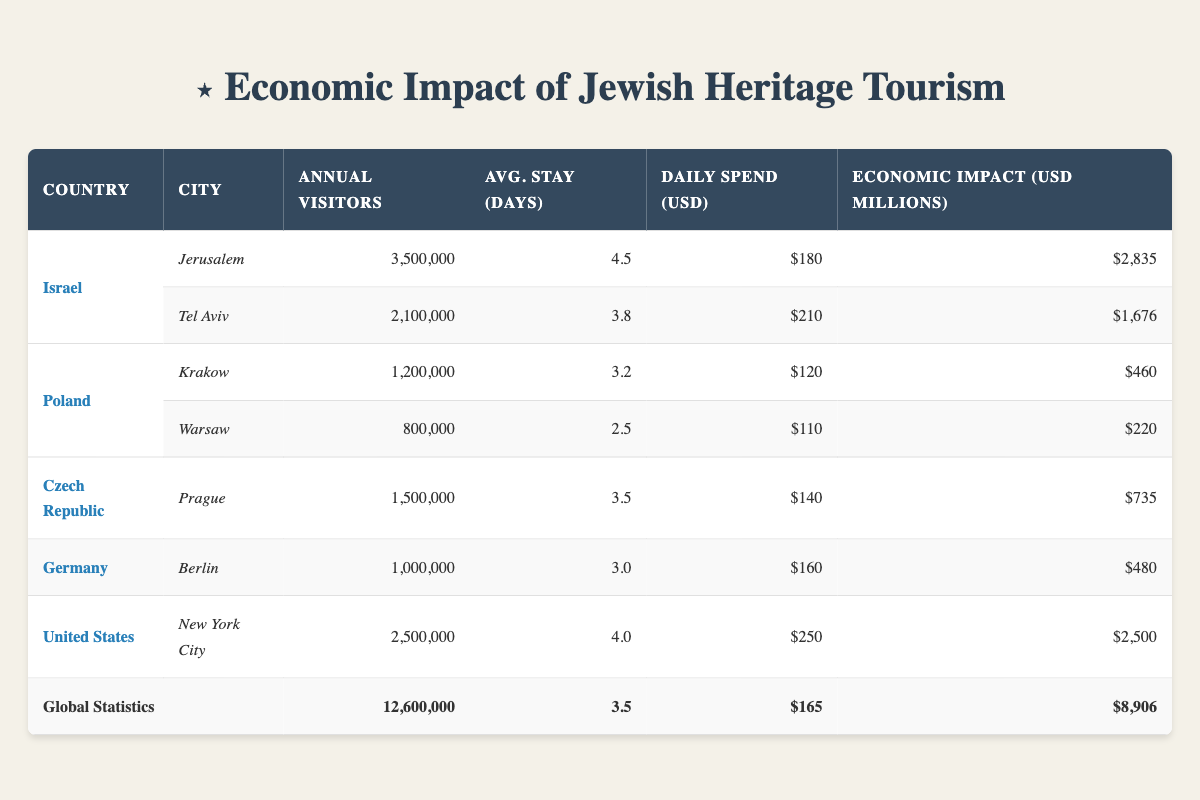What is the total economic impact of Jewish heritage tourism in Israel? Israel has two cities listed: Jerusalem with an economic impact of 2835 million dollars and Tel Aviv with 1676 million dollars. Adding these together gives us: 2835 + 1676 = 4511 million dollars.
Answer: 4511 million dollars Which city in Poland has a higher daily spending rate by visitors? In Poland, Krakow has a daily spend of 120 dollars, while Warsaw has a daily spend of 110 dollars. Comparing these two values, Krakow's 120 dollars is greater than Warsaw's 110 dollars.
Answer: Krakow What is the average number of days tourists stay in Czech Republic? The only city listed for the Czech Republic is Prague with an average stay of 3.5 days. As there is only one data point, the average is simply 3.5 days.
Answer: 3.5 days Is the total number of annual visitors to the United States greater than the number of visitors to Germany and Czech Republic combined? The United States has 2,500,000 annual visitors. Germany has 1,000,000 and the Czech Republic has 1,500,000. Adding Germany and Czech Republic together: 1,000,000 + 1,500,000 = 2,500,000. The total for Germany and Czech Republic (2,500,000) is equal to the total for the United States (2,500,000), not greater.
Answer: No What is the global average daily spend of visitors? The global statistics indicate an average daily spend of 165 dollars. This value is presented in the table under global statistics without any need for calculation.
Answer: 165 dollars Which country has the highest economic impact from Jewish heritage tourism? Israel has the highest economic impact with 4511 million dollars when combining Jerusalem and Tel Aviv. Comparing this with other countries (Poland's 680 million, Czech Republic's 735 million, Germany's 480 million, and the USA's 2500 million), Israel's figure is the highest.
Answer: Israel How many total annual visitors are there across all the countries listed? The global statistics summarize the total annual visitors as 12,600,000, so we do not need to calculate it from individual countries. It is stated directly in the table.
Answer: 12,600,000 Calculate the economic impact of the three countries with the lowest individual economic impact. Poland's total from Krakow (460 million) and Warsaw (220 million) is 680 million. Germany contributes 480 million. Adding these gives us: 680 + 480 = 1160 million. Hence, the total economic impact of the three lowest is 1160 million.
Answer: 1160 million dollars 